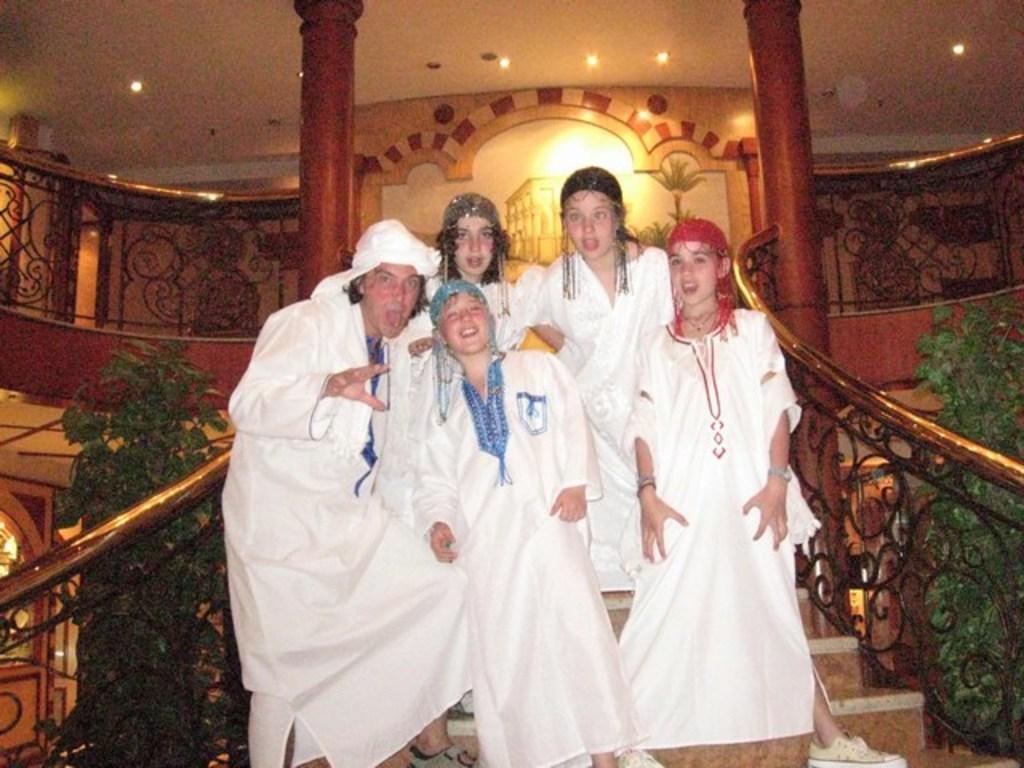Could you give a brief overview of what you see in this image? In this picture I can see five persons standing on the stairs, there are house plants, lights and iron grilles. 